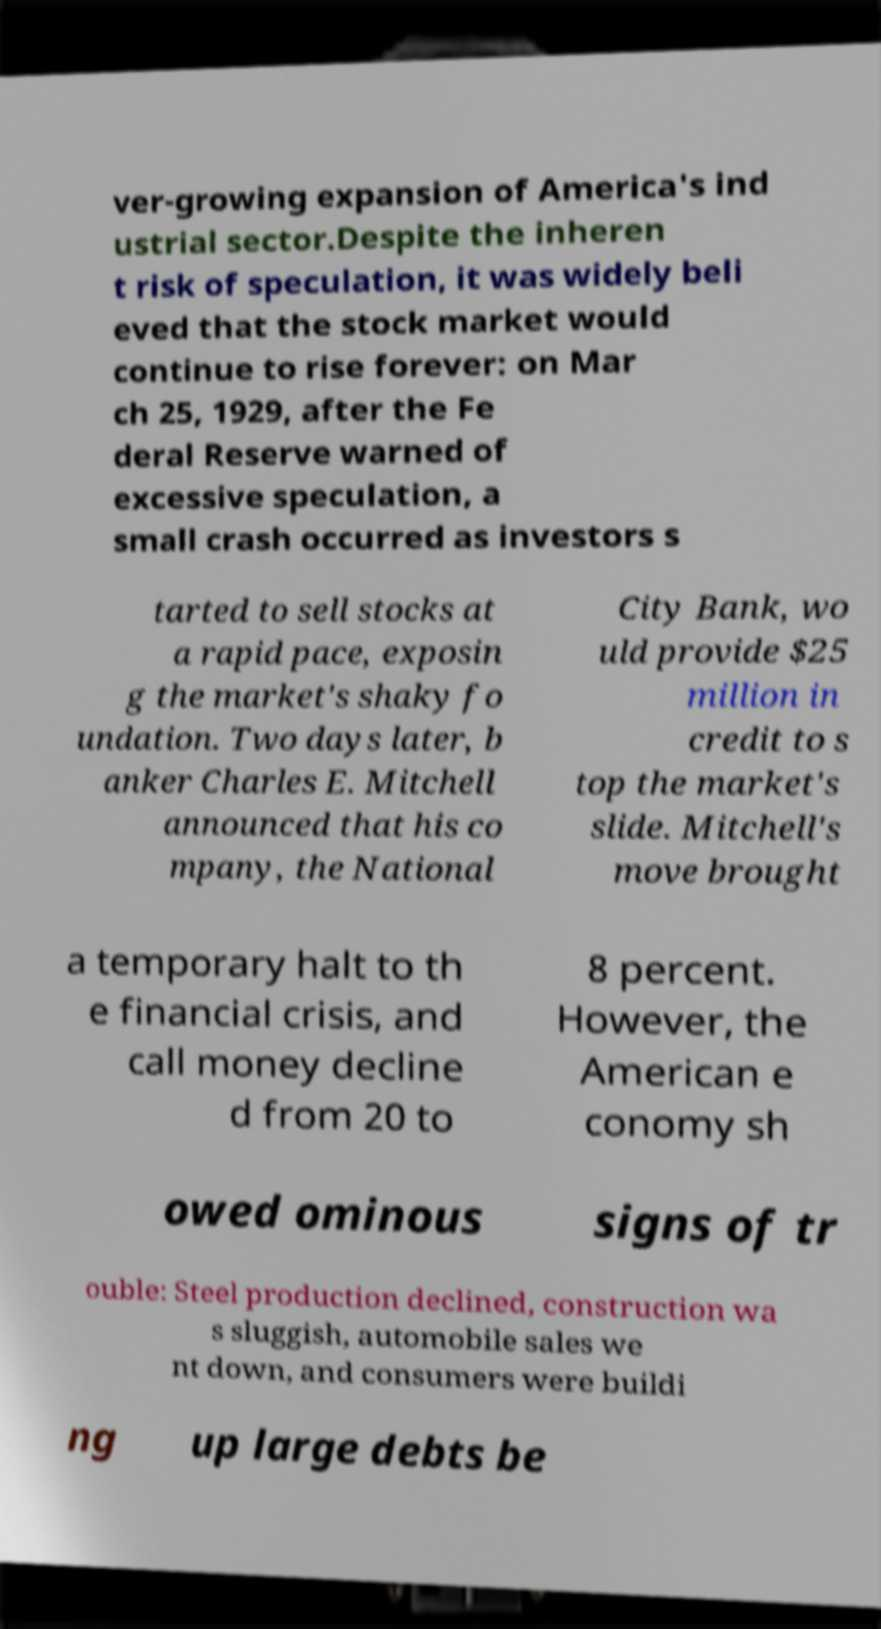For documentation purposes, I need the text within this image transcribed. Could you provide that? ver-growing expansion of America's ind ustrial sector.Despite the inheren t risk of speculation, it was widely beli eved that the stock market would continue to rise forever: on Mar ch 25, 1929, after the Fe deral Reserve warned of excessive speculation, a small crash occurred as investors s tarted to sell stocks at a rapid pace, exposin g the market's shaky fo undation. Two days later, b anker Charles E. Mitchell announced that his co mpany, the National City Bank, wo uld provide $25 million in credit to s top the market's slide. Mitchell's move brought a temporary halt to th e financial crisis, and call money decline d from 20 to 8 percent. However, the American e conomy sh owed ominous signs of tr ouble: Steel production declined, construction wa s sluggish, automobile sales we nt down, and consumers were buildi ng up large debts be 